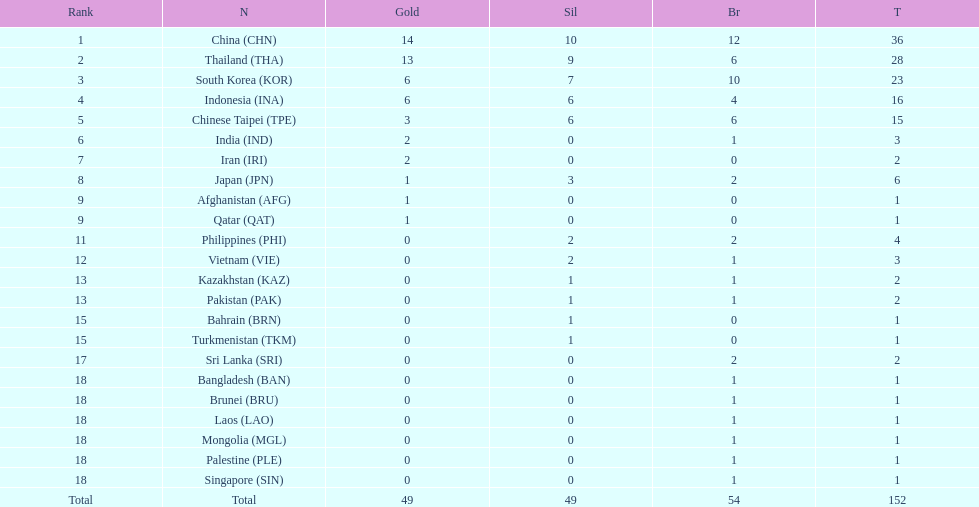How many total gold medal have been given? 49. 